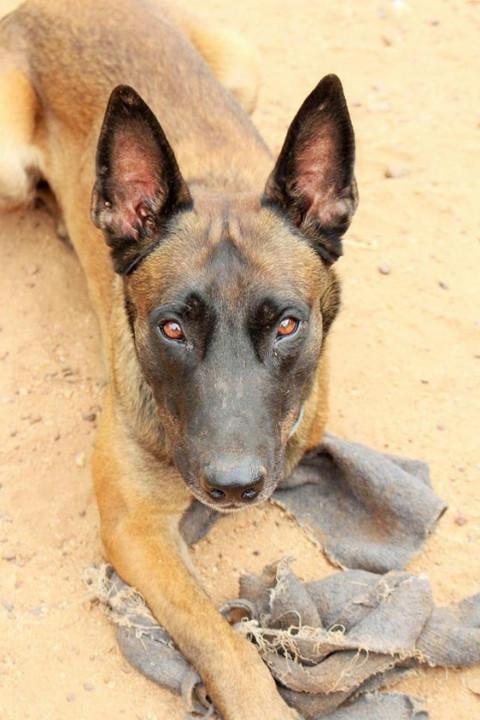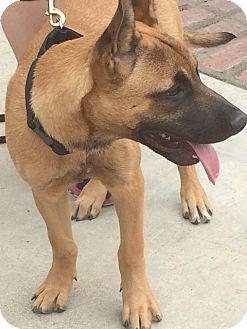The first image is the image on the left, the second image is the image on the right. Analyze the images presented: Is the assertion "The dog in the image on the right is wearing a collar." valid? Answer yes or no. Yes. The first image is the image on the left, the second image is the image on the right. Given the left and right images, does the statement "One image contains a puppy standing on all fours, and the other contains a dog with upright ears wearing a red collar." hold true? Answer yes or no. No. 